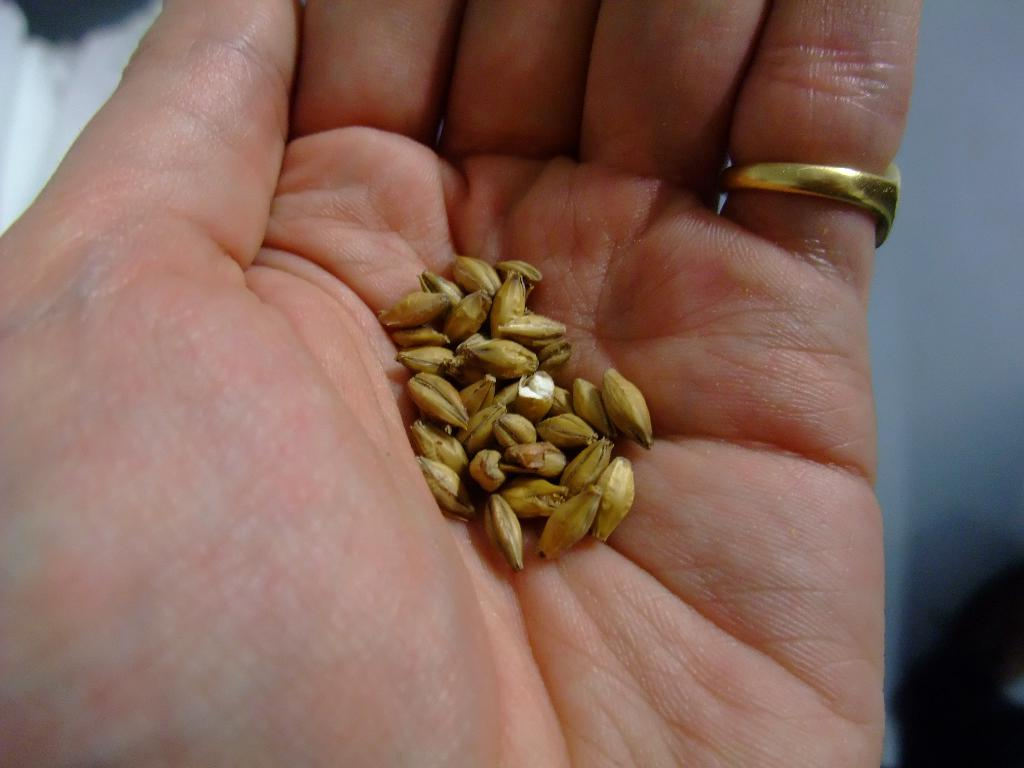What part of the human body is visible in the image? There is a human hand in the image. What is on the finger of the hand? A ring is present on the finger of the hand. What is inside the hand? There are grains in the hand. Where is the crayon located in the image? There is no crayon present in the image. 